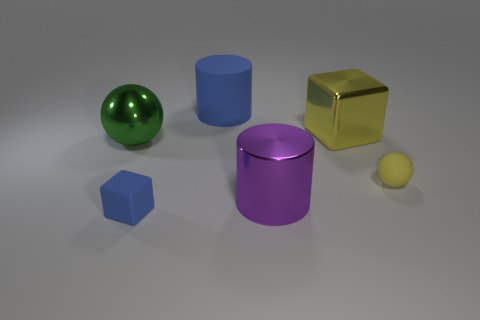Add 1 gray matte balls. How many objects exist? 7 Subtract all cylinders. How many objects are left? 4 Subtract all rubber spheres. Subtract all blue cylinders. How many objects are left? 4 Add 2 small rubber blocks. How many small rubber blocks are left? 3 Add 4 yellow matte spheres. How many yellow matte spheres exist? 5 Subtract 1 yellow balls. How many objects are left? 5 